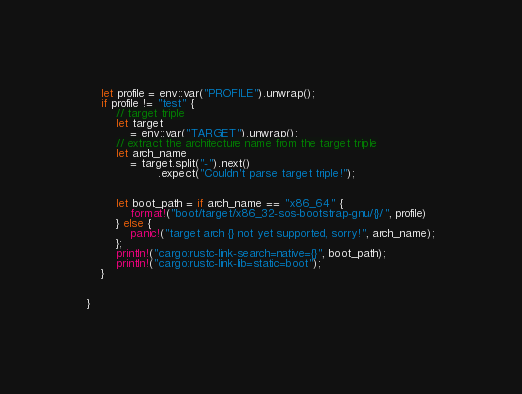Convert code to text. <code><loc_0><loc_0><loc_500><loc_500><_Rust_>    let profile = env::var("PROFILE").unwrap();
    if profile != "test" {
        // target triple
        let target
            = env::var("TARGET").unwrap();
        // extract the architecture name from the target triple
        let arch_name
            = target.split("-").next()
                    .expect("Couldn't parse target triple!");


        let boot_path = if arch_name == "x86_64" {
            format!("boot/target/x86_32-sos-bootstrap-gnu/{}/", profile)
        } else {
            panic!("target arch {} not yet supported, sorry!", arch_name);
        };
        println!("cargo:rustc-link-search=native={}", boot_path);
        println!("cargo:rustc-link-lib=static=boot");
    }


}
</code> 